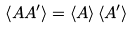<formula> <loc_0><loc_0><loc_500><loc_500>\left \langle A A ^ { \prime } \right \rangle = \left \langle A \right \rangle \left \langle A ^ { \prime } \right \rangle</formula> 